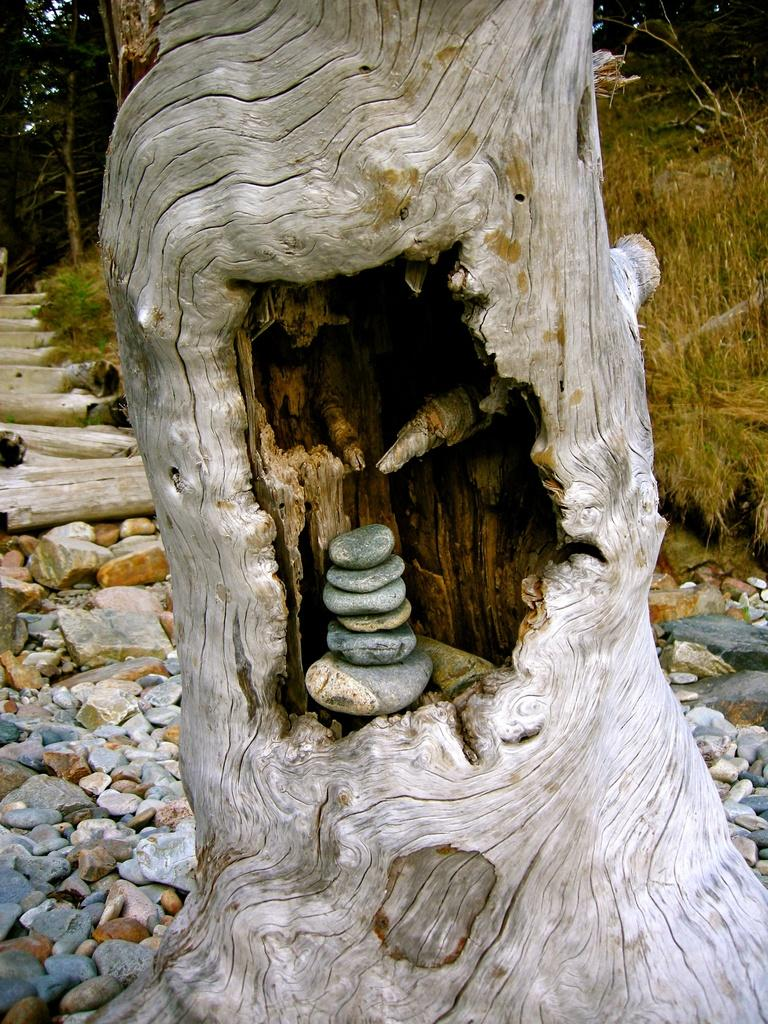What is unique about the tree in the image? There is a hole in the trunk of the tree. What is placed inside the hole in the tree? Stones are kept in the hole. What can be seen on the ground in the background of the image? There are more stones on the ground in the background. What architectural feature is visible in the background? There are steps visible in the background. What type of vegetation is present in the background? Grass and trees are visible in the background. What type of haircut does the squirrel have in the image? There is no squirrel present in the image, so it is not possible to determine its haircut. 